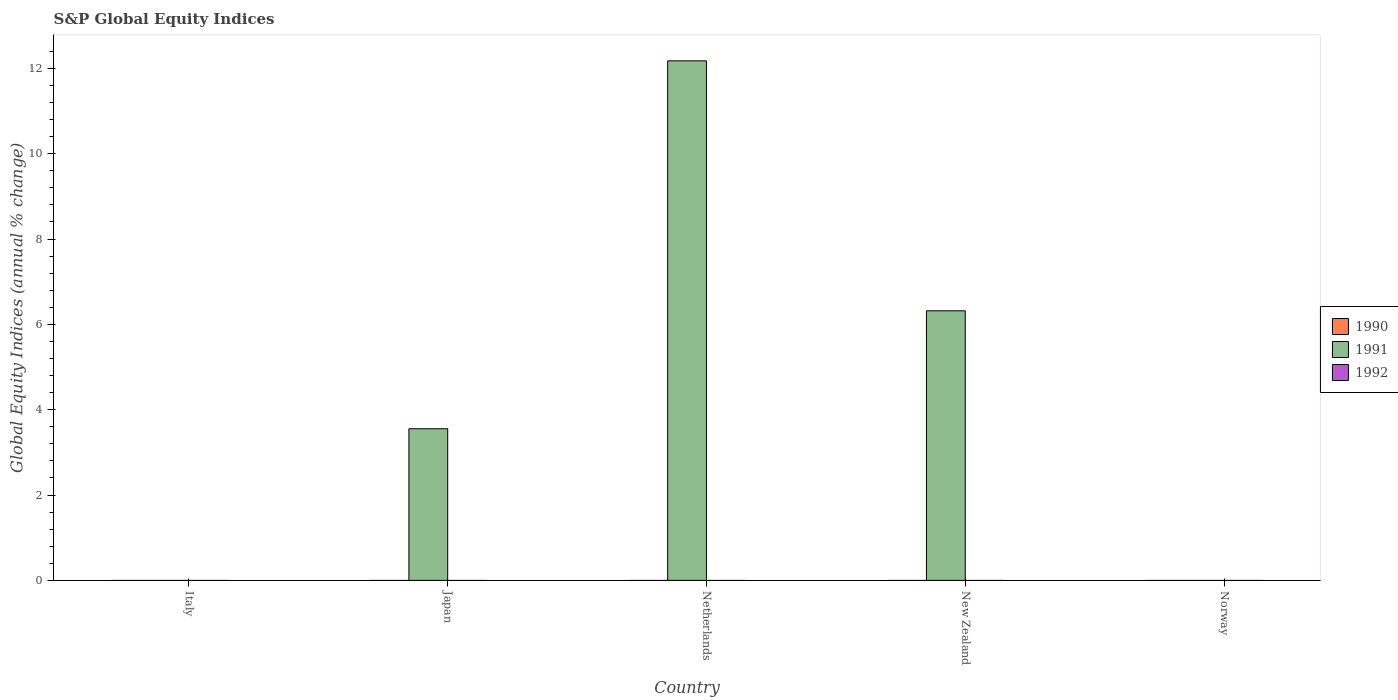How many different coloured bars are there?
Ensure brevity in your answer.  1. How many bars are there on the 1st tick from the left?
Your response must be concise. 0. How many bars are there on the 2nd tick from the right?
Offer a very short reply. 1. What is the label of the 2nd group of bars from the left?
Give a very brief answer. Japan. Across all countries, what is the maximum global equity indices in 1991?
Your response must be concise. 12.18. Across all countries, what is the minimum global equity indices in 1991?
Make the answer very short. 0. In which country was the global equity indices in 1991 maximum?
Give a very brief answer. Netherlands. What is the difference between the global equity indices in 1991 in Japan and that in Netherlands?
Ensure brevity in your answer.  -8.62. What is the ratio of the global equity indices in 1991 in Japan to that in Netherlands?
Provide a short and direct response. 0.29. What is the difference between the highest and the second highest global equity indices in 1991?
Keep it short and to the point. -8.62. What is the difference between the highest and the lowest global equity indices in 1991?
Offer a very short reply. 12.18. Is it the case that in every country, the sum of the global equity indices in 1992 and global equity indices in 1991 is greater than the global equity indices in 1990?
Make the answer very short. No. Are all the bars in the graph horizontal?
Give a very brief answer. No. What is the difference between two consecutive major ticks on the Y-axis?
Your answer should be compact. 2. Are the values on the major ticks of Y-axis written in scientific E-notation?
Provide a short and direct response. No. Does the graph contain any zero values?
Offer a terse response. Yes. How many legend labels are there?
Provide a succinct answer. 3. What is the title of the graph?
Your answer should be compact. S&P Global Equity Indices. What is the label or title of the Y-axis?
Give a very brief answer. Global Equity Indices (annual % change). What is the Global Equity Indices (annual % change) in 1990 in Italy?
Offer a terse response. 0. What is the Global Equity Indices (annual % change) of 1991 in Japan?
Ensure brevity in your answer.  3.55. What is the Global Equity Indices (annual % change) in 1991 in Netherlands?
Keep it short and to the point. 12.18. What is the Global Equity Indices (annual % change) of 1990 in New Zealand?
Make the answer very short. 0. What is the Global Equity Indices (annual % change) of 1991 in New Zealand?
Your answer should be compact. 6.32. What is the Global Equity Indices (annual % change) in 1991 in Norway?
Give a very brief answer. 0. Across all countries, what is the maximum Global Equity Indices (annual % change) in 1991?
Provide a succinct answer. 12.18. Across all countries, what is the minimum Global Equity Indices (annual % change) of 1991?
Make the answer very short. 0. What is the total Global Equity Indices (annual % change) of 1990 in the graph?
Make the answer very short. 0. What is the total Global Equity Indices (annual % change) of 1991 in the graph?
Provide a succinct answer. 22.05. What is the difference between the Global Equity Indices (annual % change) in 1991 in Japan and that in Netherlands?
Offer a very short reply. -8.62. What is the difference between the Global Equity Indices (annual % change) of 1991 in Japan and that in New Zealand?
Your answer should be very brief. -2.76. What is the difference between the Global Equity Indices (annual % change) in 1991 in Netherlands and that in New Zealand?
Offer a terse response. 5.86. What is the average Global Equity Indices (annual % change) of 1991 per country?
Your response must be concise. 4.41. What is the ratio of the Global Equity Indices (annual % change) of 1991 in Japan to that in Netherlands?
Your answer should be very brief. 0.29. What is the ratio of the Global Equity Indices (annual % change) of 1991 in Japan to that in New Zealand?
Make the answer very short. 0.56. What is the ratio of the Global Equity Indices (annual % change) of 1991 in Netherlands to that in New Zealand?
Your answer should be very brief. 1.93. What is the difference between the highest and the second highest Global Equity Indices (annual % change) in 1991?
Offer a very short reply. 5.86. What is the difference between the highest and the lowest Global Equity Indices (annual % change) of 1991?
Your answer should be very brief. 12.18. 